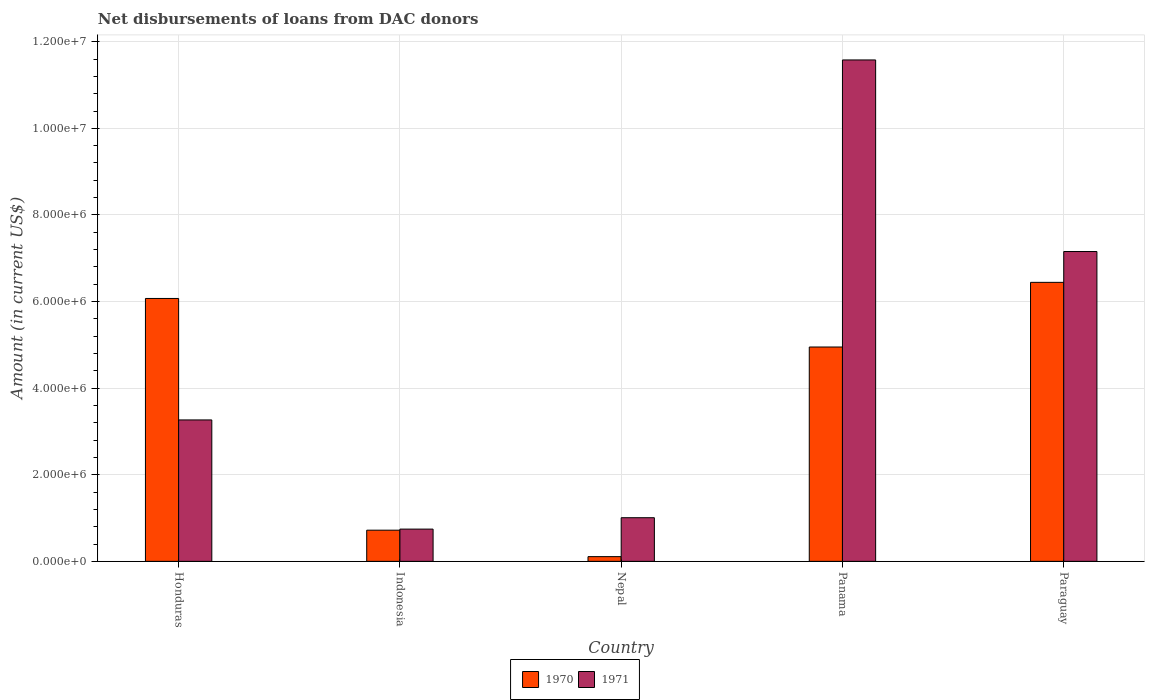How many groups of bars are there?
Make the answer very short. 5. Are the number of bars per tick equal to the number of legend labels?
Keep it short and to the point. Yes. How many bars are there on the 1st tick from the left?
Provide a short and direct response. 2. What is the label of the 3rd group of bars from the left?
Give a very brief answer. Nepal. What is the amount of loans disbursed in 1970 in Honduras?
Make the answer very short. 6.07e+06. Across all countries, what is the maximum amount of loans disbursed in 1970?
Your response must be concise. 6.44e+06. Across all countries, what is the minimum amount of loans disbursed in 1970?
Keep it short and to the point. 1.09e+05. In which country was the amount of loans disbursed in 1971 maximum?
Provide a short and direct response. Panama. In which country was the amount of loans disbursed in 1970 minimum?
Provide a succinct answer. Nepal. What is the total amount of loans disbursed in 1970 in the graph?
Your answer should be compact. 1.83e+07. What is the difference between the amount of loans disbursed in 1970 in Honduras and that in Nepal?
Your answer should be compact. 5.96e+06. What is the difference between the amount of loans disbursed in 1971 in Nepal and the amount of loans disbursed in 1970 in Honduras?
Offer a terse response. -5.06e+06. What is the average amount of loans disbursed in 1971 per country?
Your answer should be very brief. 4.75e+06. What is the difference between the amount of loans disbursed of/in 1971 and amount of loans disbursed of/in 1970 in Panama?
Offer a very short reply. 6.63e+06. In how many countries, is the amount of loans disbursed in 1971 greater than 3200000 US$?
Your answer should be very brief. 3. What is the ratio of the amount of loans disbursed in 1971 in Honduras to that in Nepal?
Give a very brief answer. 3.24. Is the amount of loans disbursed in 1971 in Nepal less than that in Panama?
Make the answer very short. Yes. Is the difference between the amount of loans disbursed in 1971 in Honduras and Panama greater than the difference between the amount of loans disbursed in 1970 in Honduras and Panama?
Provide a succinct answer. No. What is the difference between the highest and the second highest amount of loans disbursed in 1971?
Keep it short and to the point. 4.42e+06. What is the difference between the highest and the lowest amount of loans disbursed in 1971?
Make the answer very short. 1.08e+07. What does the 2nd bar from the left in Paraguay represents?
Offer a terse response. 1971. What does the 1st bar from the right in Panama represents?
Offer a very short reply. 1971. Are all the bars in the graph horizontal?
Offer a very short reply. No. What is the difference between two consecutive major ticks on the Y-axis?
Your answer should be compact. 2.00e+06. Are the values on the major ticks of Y-axis written in scientific E-notation?
Ensure brevity in your answer.  Yes. How many legend labels are there?
Your answer should be very brief. 2. What is the title of the graph?
Offer a terse response. Net disbursements of loans from DAC donors. Does "1976" appear as one of the legend labels in the graph?
Keep it short and to the point. No. What is the label or title of the X-axis?
Offer a very short reply. Country. What is the label or title of the Y-axis?
Keep it short and to the point. Amount (in current US$). What is the Amount (in current US$) of 1970 in Honduras?
Your answer should be very brief. 6.07e+06. What is the Amount (in current US$) in 1971 in Honduras?
Your answer should be very brief. 3.27e+06. What is the Amount (in current US$) in 1970 in Indonesia?
Offer a terse response. 7.20e+05. What is the Amount (in current US$) of 1971 in Indonesia?
Offer a very short reply. 7.45e+05. What is the Amount (in current US$) in 1970 in Nepal?
Provide a short and direct response. 1.09e+05. What is the Amount (in current US$) of 1971 in Nepal?
Offer a terse response. 1.01e+06. What is the Amount (in current US$) of 1970 in Panama?
Your answer should be compact. 4.95e+06. What is the Amount (in current US$) of 1971 in Panama?
Make the answer very short. 1.16e+07. What is the Amount (in current US$) of 1970 in Paraguay?
Offer a very short reply. 6.44e+06. What is the Amount (in current US$) in 1971 in Paraguay?
Offer a terse response. 7.16e+06. Across all countries, what is the maximum Amount (in current US$) of 1970?
Give a very brief answer. 6.44e+06. Across all countries, what is the maximum Amount (in current US$) in 1971?
Offer a terse response. 1.16e+07. Across all countries, what is the minimum Amount (in current US$) in 1970?
Offer a very short reply. 1.09e+05. Across all countries, what is the minimum Amount (in current US$) in 1971?
Ensure brevity in your answer.  7.45e+05. What is the total Amount (in current US$) in 1970 in the graph?
Give a very brief answer. 1.83e+07. What is the total Amount (in current US$) in 1971 in the graph?
Offer a very short reply. 2.38e+07. What is the difference between the Amount (in current US$) of 1970 in Honduras and that in Indonesia?
Make the answer very short. 5.35e+06. What is the difference between the Amount (in current US$) in 1971 in Honduras and that in Indonesia?
Ensure brevity in your answer.  2.52e+06. What is the difference between the Amount (in current US$) of 1970 in Honduras and that in Nepal?
Provide a short and direct response. 5.96e+06. What is the difference between the Amount (in current US$) of 1971 in Honduras and that in Nepal?
Provide a short and direct response. 2.26e+06. What is the difference between the Amount (in current US$) in 1970 in Honduras and that in Panama?
Your response must be concise. 1.12e+06. What is the difference between the Amount (in current US$) in 1971 in Honduras and that in Panama?
Your answer should be very brief. -8.31e+06. What is the difference between the Amount (in current US$) of 1970 in Honduras and that in Paraguay?
Your response must be concise. -3.72e+05. What is the difference between the Amount (in current US$) of 1971 in Honduras and that in Paraguay?
Keep it short and to the point. -3.89e+06. What is the difference between the Amount (in current US$) of 1970 in Indonesia and that in Nepal?
Provide a short and direct response. 6.11e+05. What is the difference between the Amount (in current US$) of 1971 in Indonesia and that in Nepal?
Make the answer very short. -2.63e+05. What is the difference between the Amount (in current US$) of 1970 in Indonesia and that in Panama?
Give a very brief answer. -4.23e+06. What is the difference between the Amount (in current US$) in 1971 in Indonesia and that in Panama?
Offer a very short reply. -1.08e+07. What is the difference between the Amount (in current US$) in 1970 in Indonesia and that in Paraguay?
Offer a very short reply. -5.72e+06. What is the difference between the Amount (in current US$) in 1971 in Indonesia and that in Paraguay?
Make the answer very short. -6.41e+06. What is the difference between the Amount (in current US$) of 1970 in Nepal and that in Panama?
Your answer should be very brief. -4.84e+06. What is the difference between the Amount (in current US$) in 1971 in Nepal and that in Panama?
Your answer should be compact. -1.06e+07. What is the difference between the Amount (in current US$) of 1970 in Nepal and that in Paraguay?
Ensure brevity in your answer.  -6.33e+06. What is the difference between the Amount (in current US$) of 1971 in Nepal and that in Paraguay?
Ensure brevity in your answer.  -6.15e+06. What is the difference between the Amount (in current US$) in 1970 in Panama and that in Paraguay?
Your answer should be very brief. -1.49e+06. What is the difference between the Amount (in current US$) of 1971 in Panama and that in Paraguay?
Offer a terse response. 4.42e+06. What is the difference between the Amount (in current US$) of 1970 in Honduras and the Amount (in current US$) of 1971 in Indonesia?
Offer a terse response. 5.33e+06. What is the difference between the Amount (in current US$) of 1970 in Honduras and the Amount (in current US$) of 1971 in Nepal?
Provide a short and direct response. 5.06e+06. What is the difference between the Amount (in current US$) in 1970 in Honduras and the Amount (in current US$) in 1971 in Panama?
Provide a succinct answer. -5.51e+06. What is the difference between the Amount (in current US$) in 1970 in Honduras and the Amount (in current US$) in 1971 in Paraguay?
Make the answer very short. -1.08e+06. What is the difference between the Amount (in current US$) in 1970 in Indonesia and the Amount (in current US$) in 1971 in Nepal?
Offer a terse response. -2.88e+05. What is the difference between the Amount (in current US$) of 1970 in Indonesia and the Amount (in current US$) of 1971 in Panama?
Make the answer very short. -1.09e+07. What is the difference between the Amount (in current US$) of 1970 in Indonesia and the Amount (in current US$) of 1971 in Paraguay?
Keep it short and to the point. -6.44e+06. What is the difference between the Amount (in current US$) in 1970 in Nepal and the Amount (in current US$) in 1971 in Panama?
Offer a very short reply. -1.15e+07. What is the difference between the Amount (in current US$) in 1970 in Nepal and the Amount (in current US$) in 1971 in Paraguay?
Provide a succinct answer. -7.05e+06. What is the difference between the Amount (in current US$) in 1970 in Panama and the Amount (in current US$) in 1971 in Paraguay?
Ensure brevity in your answer.  -2.20e+06. What is the average Amount (in current US$) in 1970 per country?
Give a very brief answer. 3.66e+06. What is the average Amount (in current US$) in 1971 per country?
Offer a terse response. 4.75e+06. What is the difference between the Amount (in current US$) in 1970 and Amount (in current US$) in 1971 in Honduras?
Provide a succinct answer. 2.80e+06. What is the difference between the Amount (in current US$) of 1970 and Amount (in current US$) of 1971 in Indonesia?
Your response must be concise. -2.50e+04. What is the difference between the Amount (in current US$) in 1970 and Amount (in current US$) in 1971 in Nepal?
Ensure brevity in your answer.  -8.99e+05. What is the difference between the Amount (in current US$) of 1970 and Amount (in current US$) of 1971 in Panama?
Provide a succinct answer. -6.63e+06. What is the difference between the Amount (in current US$) of 1970 and Amount (in current US$) of 1971 in Paraguay?
Make the answer very short. -7.12e+05. What is the ratio of the Amount (in current US$) in 1970 in Honduras to that in Indonesia?
Your answer should be very brief. 8.43. What is the ratio of the Amount (in current US$) of 1971 in Honduras to that in Indonesia?
Provide a succinct answer. 4.38. What is the ratio of the Amount (in current US$) of 1970 in Honduras to that in Nepal?
Offer a terse response. 55.7. What is the ratio of the Amount (in current US$) in 1971 in Honduras to that in Nepal?
Ensure brevity in your answer.  3.24. What is the ratio of the Amount (in current US$) in 1970 in Honduras to that in Panama?
Your answer should be very brief. 1.23. What is the ratio of the Amount (in current US$) in 1971 in Honduras to that in Panama?
Offer a terse response. 0.28. What is the ratio of the Amount (in current US$) of 1970 in Honduras to that in Paraguay?
Ensure brevity in your answer.  0.94. What is the ratio of the Amount (in current US$) in 1971 in Honduras to that in Paraguay?
Your response must be concise. 0.46. What is the ratio of the Amount (in current US$) in 1970 in Indonesia to that in Nepal?
Offer a very short reply. 6.61. What is the ratio of the Amount (in current US$) in 1971 in Indonesia to that in Nepal?
Your answer should be very brief. 0.74. What is the ratio of the Amount (in current US$) of 1970 in Indonesia to that in Panama?
Make the answer very short. 0.15. What is the ratio of the Amount (in current US$) of 1971 in Indonesia to that in Panama?
Make the answer very short. 0.06. What is the ratio of the Amount (in current US$) in 1970 in Indonesia to that in Paraguay?
Provide a short and direct response. 0.11. What is the ratio of the Amount (in current US$) of 1971 in Indonesia to that in Paraguay?
Provide a succinct answer. 0.1. What is the ratio of the Amount (in current US$) in 1970 in Nepal to that in Panama?
Provide a succinct answer. 0.02. What is the ratio of the Amount (in current US$) in 1971 in Nepal to that in Panama?
Keep it short and to the point. 0.09. What is the ratio of the Amount (in current US$) in 1970 in Nepal to that in Paraguay?
Make the answer very short. 0.02. What is the ratio of the Amount (in current US$) of 1971 in Nepal to that in Paraguay?
Provide a succinct answer. 0.14. What is the ratio of the Amount (in current US$) in 1970 in Panama to that in Paraguay?
Your response must be concise. 0.77. What is the ratio of the Amount (in current US$) of 1971 in Panama to that in Paraguay?
Provide a short and direct response. 1.62. What is the difference between the highest and the second highest Amount (in current US$) of 1970?
Your response must be concise. 3.72e+05. What is the difference between the highest and the second highest Amount (in current US$) of 1971?
Offer a terse response. 4.42e+06. What is the difference between the highest and the lowest Amount (in current US$) of 1970?
Your answer should be compact. 6.33e+06. What is the difference between the highest and the lowest Amount (in current US$) in 1971?
Give a very brief answer. 1.08e+07. 